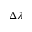<formula> <loc_0><loc_0><loc_500><loc_500>\Delta \lambda</formula> 